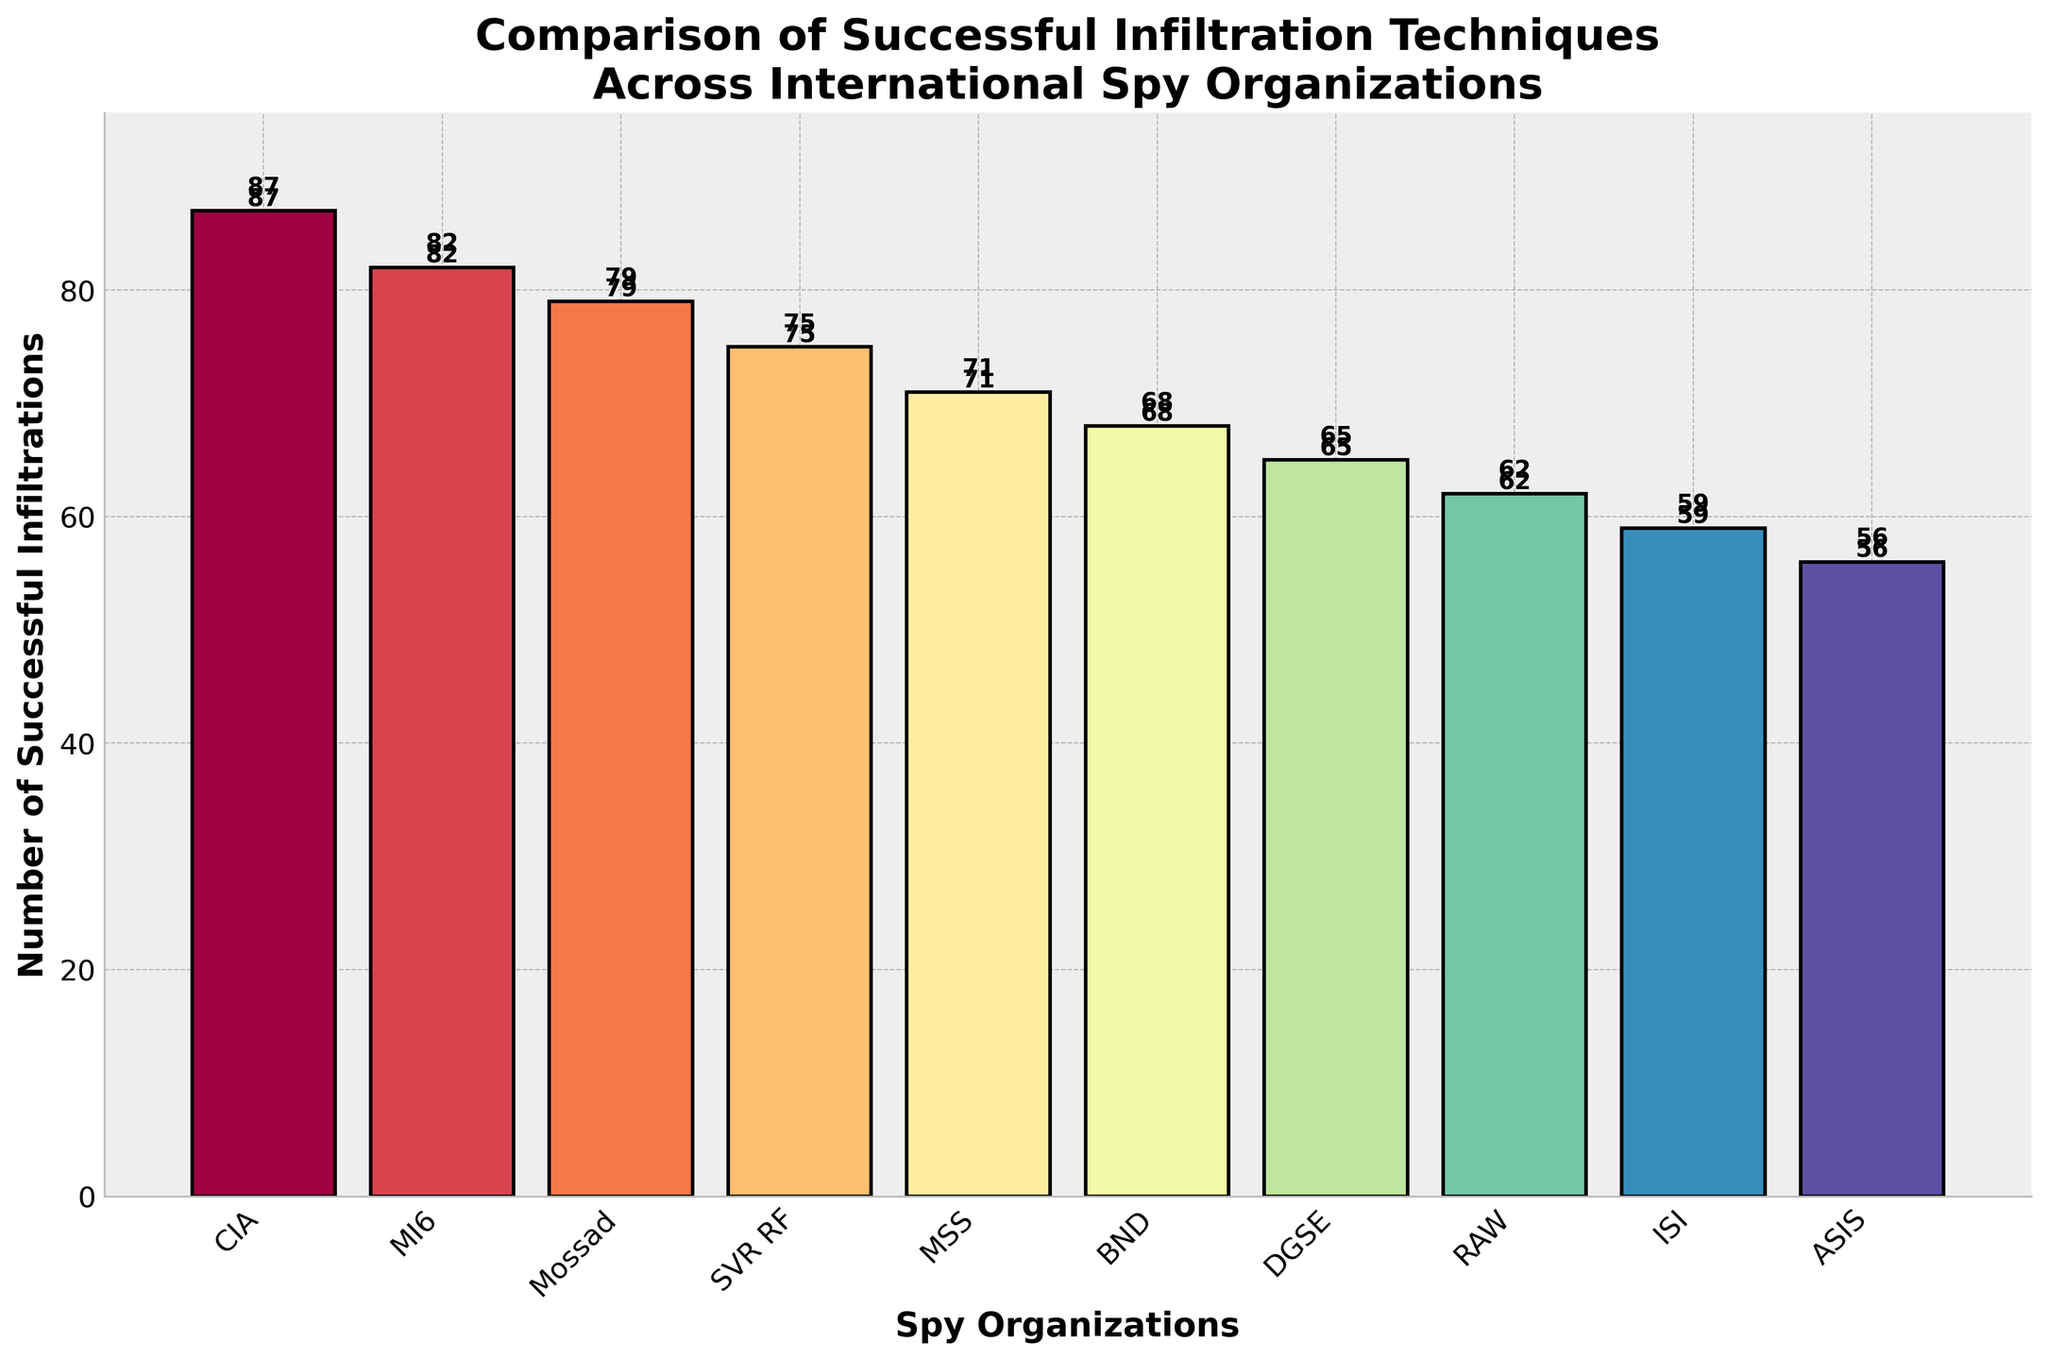Which spy organization has the highest number of successful infiltrations? The organization with the tallest bar represents the highest number of successful infiltrations. The CIA has the tallest bar.
Answer: CIA Which spy organization has the fewest successful infiltrations? The organization with the shortest bar represents the fewest number of successful infiltrations. The ASIS has the shortest bar.
Answer: ASIS What is the total number of successful infiltrations for MI6 and Mossad combined? To find the total, add the number of successful infiltrations for MI6 and Mossad: 82 (MI6) + 79 (Mossad) = 161.
Answer: 161 How many more successful infiltrations does the CIA have compared to the DGSE? Subtract the number of successful infiltrations of DGSE from those of the CIA: 87 (CIA) - 65 (DGSE) = 22.
Answer: 22 Which two organizations have the closest number of successful infiltrations? By comparing the height of the bars, find the two bars that are nearest in height. MI6 (82) and Mossad (79) have the closest numbers.
Answer: MI6 and Mossad What is the average number of successful infiltrations across all organizations? Sum up the number of successful infiltrations across all organizations and divide by the number of organizations: (87 + 82 + 79 + 75 + 71 + 68 + 65 + 62 + 59 + 56) / 10 = 70.4.
Answer: 70.4 Rank the top three spy organizations in descending order based on successful infiltrations. Order the bars from tallest to shortest and list the top three: CIA (87), MI6 (82), Mossad (79).
Answer: CIA, MI6, Mossad Which organization has more successful infiltrations: RAW or BND? Compare the heights of the bars for RAW and BND. RAW has 62 and BND has 68. BND's bar is taller.
Answer: BND If MSS increases its successful infiltrations by 5, what would be its new total, and where would it rank? Add 5 to MSS's current infiltrations: 71 + 5 = 76. This would place MSS between Mossad (79) and SVR RF (75).
Answer: New total: 76, New rank: 4th What percentage of the total successful infiltrations does the CIA account for? First, calculate the total number of successful infiltrations: 87 + 82 + 79 + 75 + 71 + 68 + 65 + 62 + 59 + 56 = 704. Then, determine the percentage for the CIA: (87 / 704) * 100 ≈ 12.36%.
Answer: 12.36% 